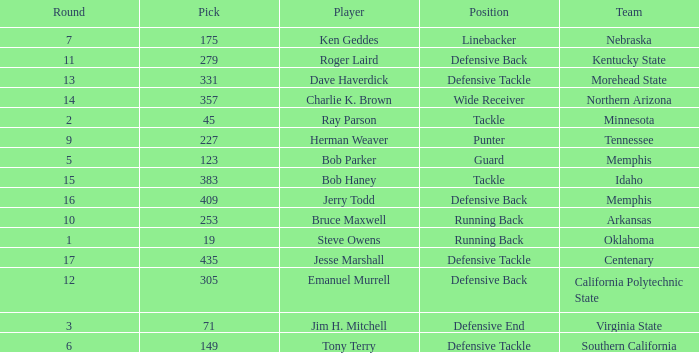What is the average pick of player jim h. mitchell? 71.0. 